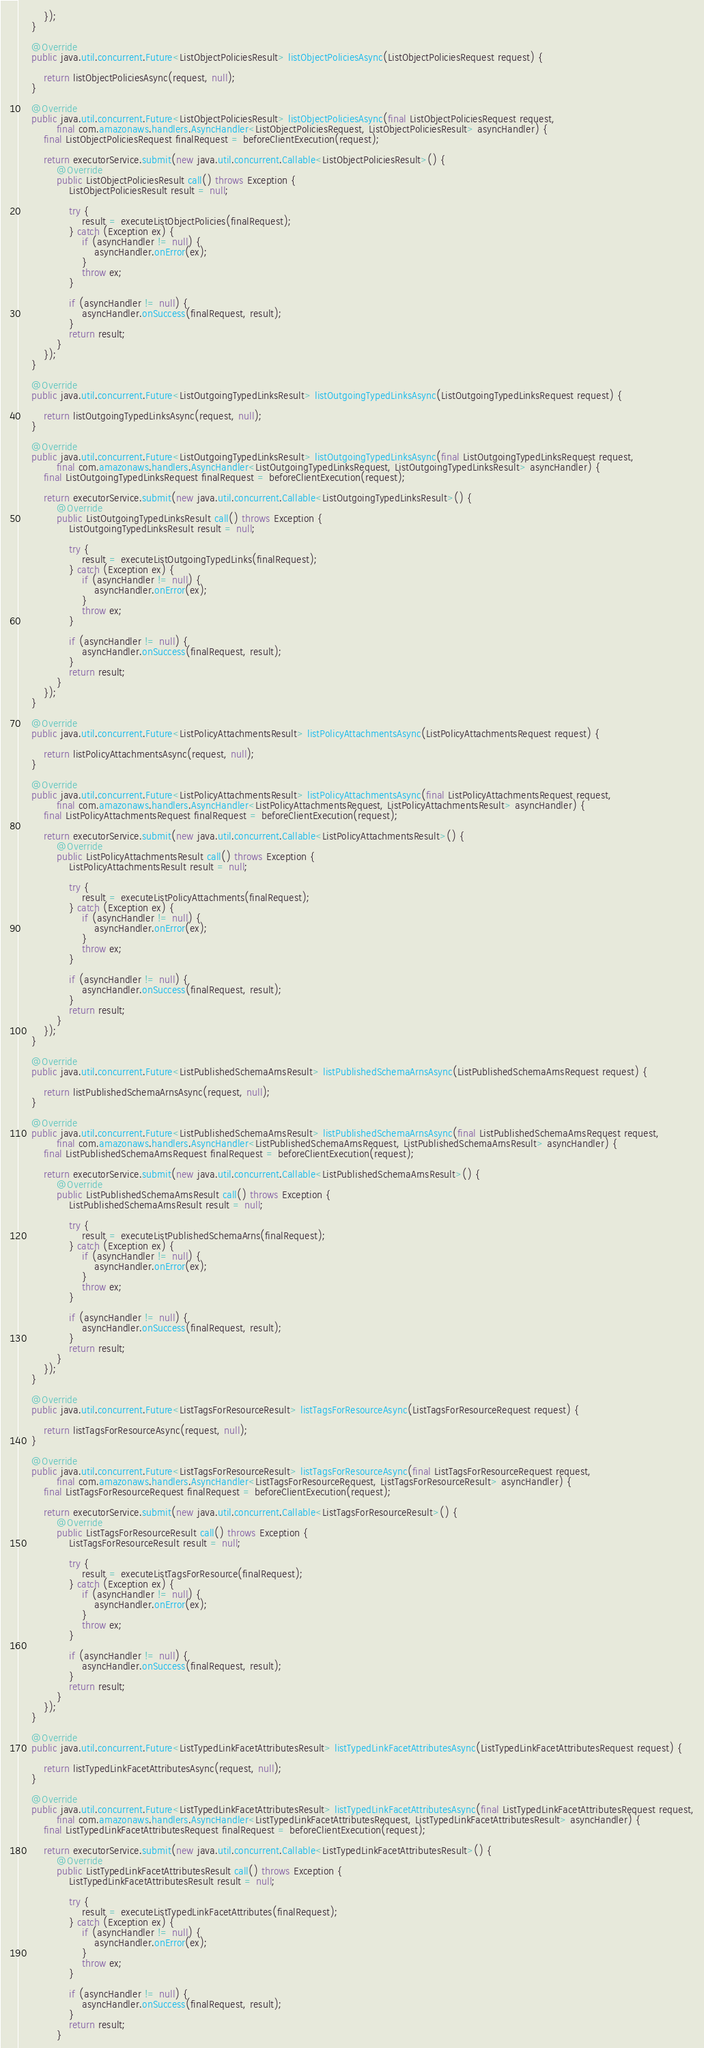<code> <loc_0><loc_0><loc_500><loc_500><_Java_>        });
    }

    @Override
    public java.util.concurrent.Future<ListObjectPoliciesResult> listObjectPoliciesAsync(ListObjectPoliciesRequest request) {

        return listObjectPoliciesAsync(request, null);
    }

    @Override
    public java.util.concurrent.Future<ListObjectPoliciesResult> listObjectPoliciesAsync(final ListObjectPoliciesRequest request,
            final com.amazonaws.handlers.AsyncHandler<ListObjectPoliciesRequest, ListObjectPoliciesResult> asyncHandler) {
        final ListObjectPoliciesRequest finalRequest = beforeClientExecution(request);

        return executorService.submit(new java.util.concurrent.Callable<ListObjectPoliciesResult>() {
            @Override
            public ListObjectPoliciesResult call() throws Exception {
                ListObjectPoliciesResult result = null;

                try {
                    result = executeListObjectPolicies(finalRequest);
                } catch (Exception ex) {
                    if (asyncHandler != null) {
                        asyncHandler.onError(ex);
                    }
                    throw ex;
                }

                if (asyncHandler != null) {
                    asyncHandler.onSuccess(finalRequest, result);
                }
                return result;
            }
        });
    }

    @Override
    public java.util.concurrent.Future<ListOutgoingTypedLinksResult> listOutgoingTypedLinksAsync(ListOutgoingTypedLinksRequest request) {

        return listOutgoingTypedLinksAsync(request, null);
    }

    @Override
    public java.util.concurrent.Future<ListOutgoingTypedLinksResult> listOutgoingTypedLinksAsync(final ListOutgoingTypedLinksRequest request,
            final com.amazonaws.handlers.AsyncHandler<ListOutgoingTypedLinksRequest, ListOutgoingTypedLinksResult> asyncHandler) {
        final ListOutgoingTypedLinksRequest finalRequest = beforeClientExecution(request);

        return executorService.submit(new java.util.concurrent.Callable<ListOutgoingTypedLinksResult>() {
            @Override
            public ListOutgoingTypedLinksResult call() throws Exception {
                ListOutgoingTypedLinksResult result = null;

                try {
                    result = executeListOutgoingTypedLinks(finalRequest);
                } catch (Exception ex) {
                    if (asyncHandler != null) {
                        asyncHandler.onError(ex);
                    }
                    throw ex;
                }

                if (asyncHandler != null) {
                    asyncHandler.onSuccess(finalRequest, result);
                }
                return result;
            }
        });
    }

    @Override
    public java.util.concurrent.Future<ListPolicyAttachmentsResult> listPolicyAttachmentsAsync(ListPolicyAttachmentsRequest request) {

        return listPolicyAttachmentsAsync(request, null);
    }

    @Override
    public java.util.concurrent.Future<ListPolicyAttachmentsResult> listPolicyAttachmentsAsync(final ListPolicyAttachmentsRequest request,
            final com.amazonaws.handlers.AsyncHandler<ListPolicyAttachmentsRequest, ListPolicyAttachmentsResult> asyncHandler) {
        final ListPolicyAttachmentsRequest finalRequest = beforeClientExecution(request);

        return executorService.submit(new java.util.concurrent.Callable<ListPolicyAttachmentsResult>() {
            @Override
            public ListPolicyAttachmentsResult call() throws Exception {
                ListPolicyAttachmentsResult result = null;

                try {
                    result = executeListPolicyAttachments(finalRequest);
                } catch (Exception ex) {
                    if (asyncHandler != null) {
                        asyncHandler.onError(ex);
                    }
                    throw ex;
                }

                if (asyncHandler != null) {
                    asyncHandler.onSuccess(finalRequest, result);
                }
                return result;
            }
        });
    }

    @Override
    public java.util.concurrent.Future<ListPublishedSchemaArnsResult> listPublishedSchemaArnsAsync(ListPublishedSchemaArnsRequest request) {

        return listPublishedSchemaArnsAsync(request, null);
    }

    @Override
    public java.util.concurrent.Future<ListPublishedSchemaArnsResult> listPublishedSchemaArnsAsync(final ListPublishedSchemaArnsRequest request,
            final com.amazonaws.handlers.AsyncHandler<ListPublishedSchemaArnsRequest, ListPublishedSchemaArnsResult> asyncHandler) {
        final ListPublishedSchemaArnsRequest finalRequest = beforeClientExecution(request);

        return executorService.submit(new java.util.concurrent.Callable<ListPublishedSchemaArnsResult>() {
            @Override
            public ListPublishedSchemaArnsResult call() throws Exception {
                ListPublishedSchemaArnsResult result = null;

                try {
                    result = executeListPublishedSchemaArns(finalRequest);
                } catch (Exception ex) {
                    if (asyncHandler != null) {
                        asyncHandler.onError(ex);
                    }
                    throw ex;
                }

                if (asyncHandler != null) {
                    asyncHandler.onSuccess(finalRequest, result);
                }
                return result;
            }
        });
    }

    @Override
    public java.util.concurrent.Future<ListTagsForResourceResult> listTagsForResourceAsync(ListTagsForResourceRequest request) {

        return listTagsForResourceAsync(request, null);
    }

    @Override
    public java.util.concurrent.Future<ListTagsForResourceResult> listTagsForResourceAsync(final ListTagsForResourceRequest request,
            final com.amazonaws.handlers.AsyncHandler<ListTagsForResourceRequest, ListTagsForResourceResult> asyncHandler) {
        final ListTagsForResourceRequest finalRequest = beforeClientExecution(request);

        return executorService.submit(new java.util.concurrent.Callable<ListTagsForResourceResult>() {
            @Override
            public ListTagsForResourceResult call() throws Exception {
                ListTagsForResourceResult result = null;

                try {
                    result = executeListTagsForResource(finalRequest);
                } catch (Exception ex) {
                    if (asyncHandler != null) {
                        asyncHandler.onError(ex);
                    }
                    throw ex;
                }

                if (asyncHandler != null) {
                    asyncHandler.onSuccess(finalRequest, result);
                }
                return result;
            }
        });
    }

    @Override
    public java.util.concurrent.Future<ListTypedLinkFacetAttributesResult> listTypedLinkFacetAttributesAsync(ListTypedLinkFacetAttributesRequest request) {

        return listTypedLinkFacetAttributesAsync(request, null);
    }

    @Override
    public java.util.concurrent.Future<ListTypedLinkFacetAttributesResult> listTypedLinkFacetAttributesAsync(final ListTypedLinkFacetAttributesRequest request,
            final com.amazonaws.handlers.AsyncHandler<ListTypedLinkFacetAttributesRequest, ListTypedLinkFacetAttributesResult> asyncHandler) {
        final ListTypedLinkFacetAttributesRequest finalRequest = beforeClientExecution(request);

        return executorService.submit(new java.util.concurrent.Callable<ListTypedLinkFacetAttributesResult>() {
            @Override
            public ListTypedLinkFacetAttributesResult call() throws Exception {
                ListTypedLinkFacetAttributesResult result = null;

                try {
                    result = executeListTypedLinkFacetAttributes(finalRequest);
                } catch (Exception ex) {
                    if (asyncHandler != null) {
                        asyncHandler.onError(ex);
                    }
                    throw ex;
                }

                if (asyncHandler != null) {
                    asyncHandler.onSuccess(finalRequest, result);
                }
                return result;
            }</code> 